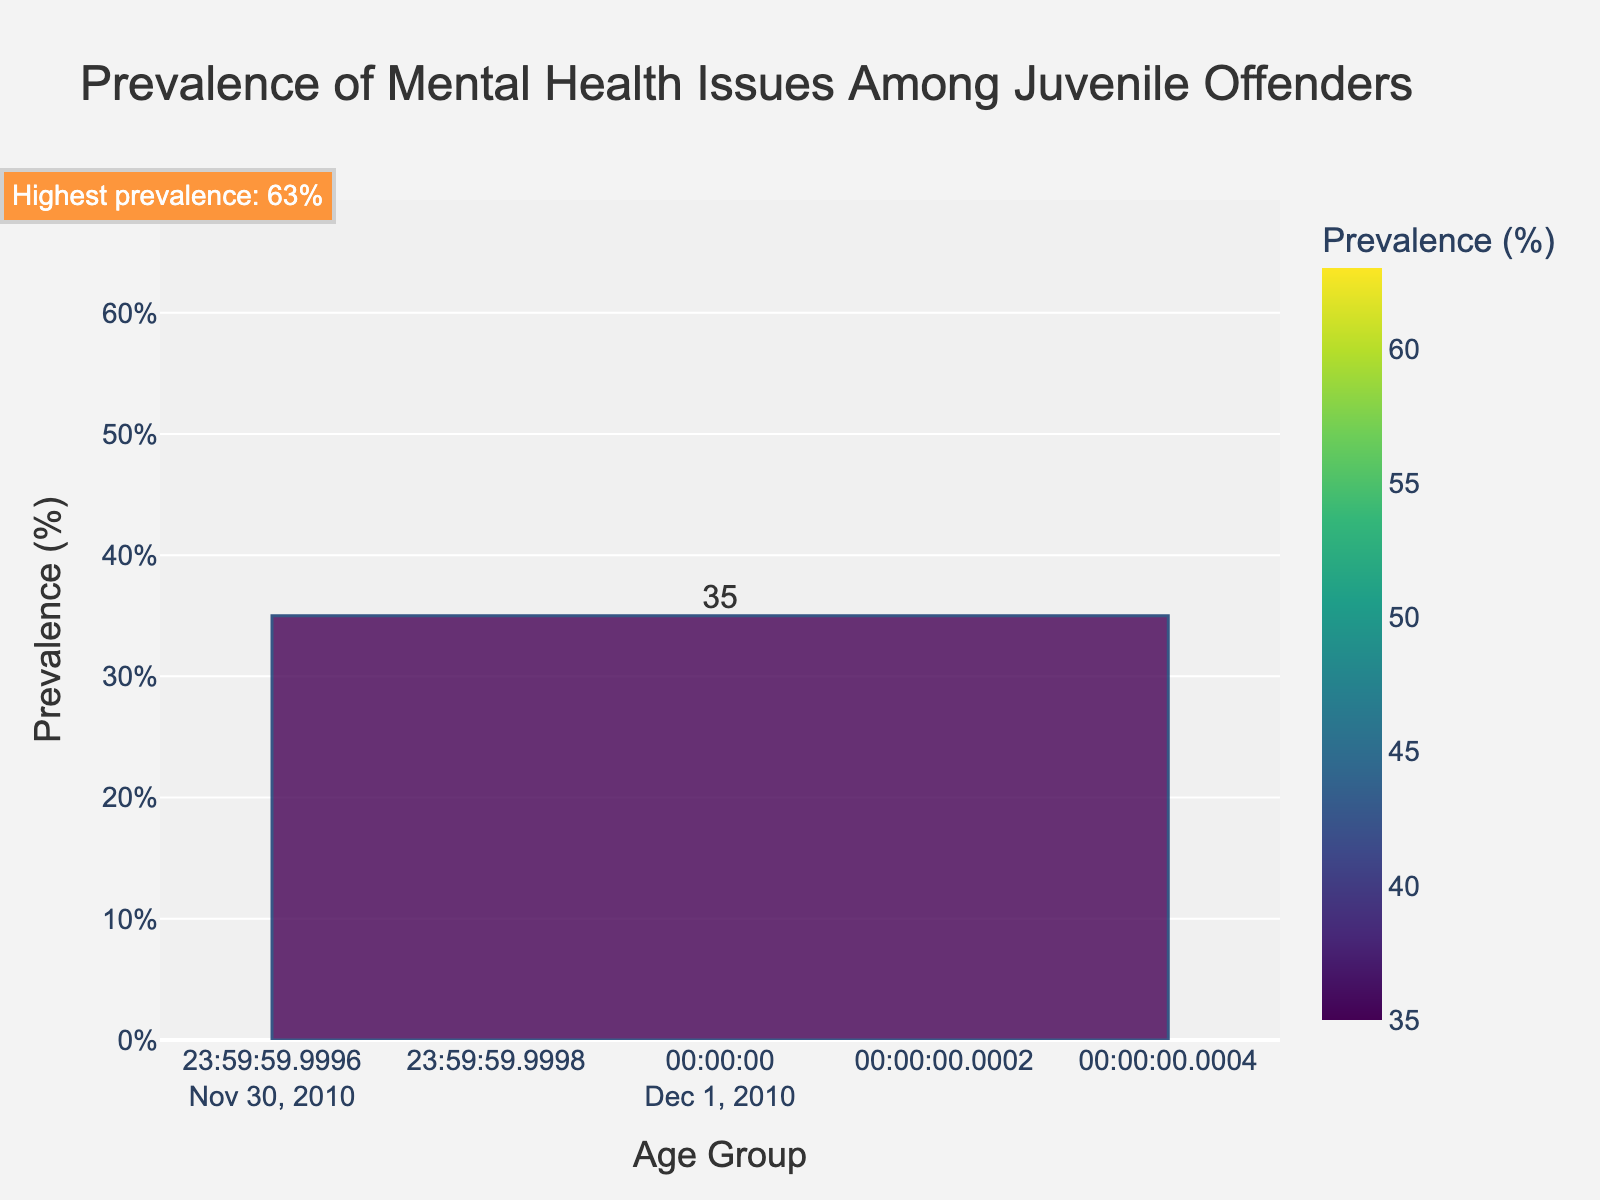Which age group has the highest prevalence of mental health issues? By inspecting the bars, the age group with the highest bar is 19-21, corresponding to 63%.
Answer: 19-21 What is the prevalence of mental health issues in the 15-16 age group? The bar for the age group 15-16 reaches up to 51% on the y-axis.
Answer: 51% How much higher is the prevalence in the 17-18 age group compared to the 13-14 age group? The prevalence for 17-18 is 58%, and for 13-14 it is 42%. The difference is 58% - 42% = 16%.
Answer: 16% Is the prevalence of mental health issues in 10-12 lower than in 19-21? The bar for the 10-12 group is visibly shorter than the bar for the 19-21 group. The prevalence in 10-12 is 35%, while in 19-21 it is 63%. 35% < 63%.
Answer: Yes Which age group shows a prevalence within the range of 50% to 60%? The bar for the age group 15-16 shows a prevalence of 51%, and the bar for the age group 17-18 shows a prevalence of 58%. Both fall within the range of 50% to 60%.
Answer: 15-16 and 17-18 Identify the age group with the lowest prevalence of mental health issues and the one with the highest. What is the difference in their prevalence? The age group with the lowest prevalence is 10-12 at 35%, and the highest is 19-21 at 63%. The difference is 63% - 35% = 28%.
Answer: 28% What is the average prevalence of mental health issues across all age groups? Sum the prevalences (35 + 42 + 51 + 58 + 63) = 249, then divide by the number of age groups (5). 249 / 5 = 49.8%.
Answer: 49.8% Are all age groups shown on the chart presented with different colors? Each bar has its own color based on the 'Prevalence (%)' variable, as indicated by the varying shades.
Answer: Yes Which age groups have a prevalence of more than 50%? From the figure, the age groups 15-16, 17-18, and 19-21 each have a prevalence greater than 50%.
Answer: 15-16, 17-18, and 19-21 Does the figure highlight any specific age group visually? If so, which one and why? The figure uses a rectangle to highlight the age group 19-21, which has the highest prevalence of mental health issues.
Answer: 19-21 